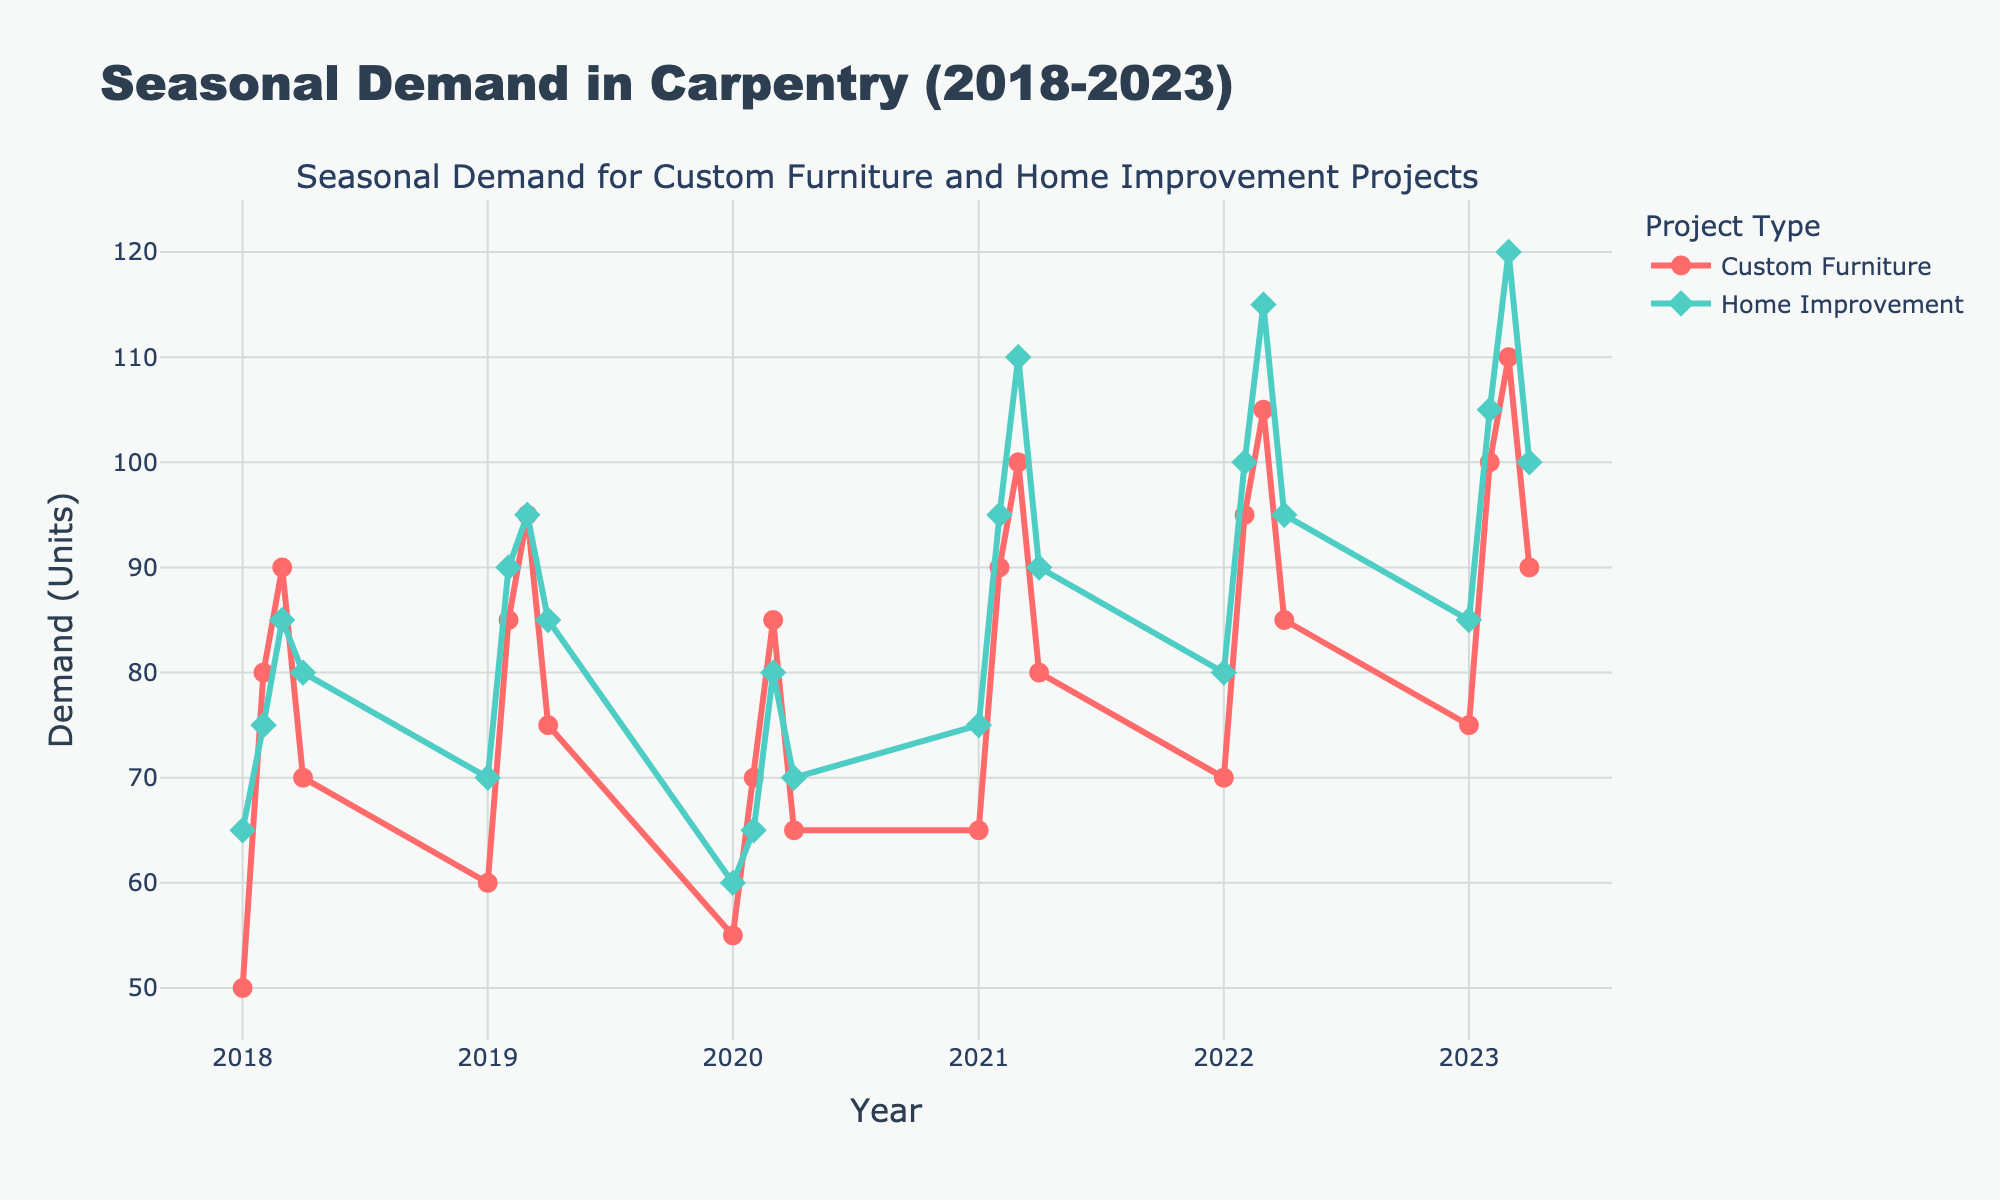What is the title of the plot? The title of the plot is located at the top center and summarizes the main content of the figure, which is the seasonal demand in carpentry from 2018 to 2023.
Answer: Seasonal Demand in Carpentry (2018-2023) How many data points are there for Custom Furniture Demand? By counting the markers or data points along the Custom Furniture Demand line in the plot, you can see there are 24 data points.
Answer: 24 What is the highest demand for Home Improvement Projects and when did it occur? The highest demand is marked by the peak point on the Home Improvement Projects line. This occurs at 120 units in Q3 of 2023.
Answer: 120 units, Q3 2023 In which quarter of which year did Custom Furniture Demand reach its lowest point? The lowest point on the Custom Furniture Demand line corresponds to the minimum value, which is 50 units in Q1 of 2018.
Answer: Q1 2018 What is the difference in demand between Custom Furniture and Home Improvement Projects in Q2 of 2022? Look at the values for both demands in Q2 of 2022 and subtract them. Custom Furniture Demand is 95 units and Home Improvement Projects Demand is 100 units. The difference is 100 - 95 = 5 units.
Answer: 5 units Which year saw the highest average quarterly demand for Custom Furniture? Calculate the average for each year by summing the quarterly values within the year and then dividing by 4. The year with the highest average is 2023: (75+100+110+90)/4 = 93.75 units.
Answer: 2023 How did the Home Improvement Projects Demand trend change from Q1 2020 to Q1 2021? Compare the demand values over the quarters in 2020 and 2021. From Q1 2020 to Q1 2021, the demand increased from 60 units to 75 units, indicating a rising trend.
Answer: Rising Did Custom Furniture Demand or Home Improvement Projects Demand have more growth from Q3 2018 to Q3 2019? Calculate the growth for each category from Q3 2018 to Q3 2019. For Custom Furniture: 95 - 90 = 5 units growth. For Home Improvement: 95 - 85 = 10 units growth.
Answer: Home Improvement Projects What is the median demand for Custom Furniture in 2021? The quarterly demand values for Custom Furniture in 2021 are 65, 90, 100, and 80. Arranging these in ascending order: 65, 80, 90, 100. The median is the average of the two middle values: (80 + 90) / 2 = 85.
Answer: 85 units Does the demand for Custom Furniture or Home Improvement Projects show more seasonality? By observing the patterns, Custom Furniture Demand has more noticeable peaks and troughs within each year, indicating stronger seasonality effects compared to Home Improvement Projects.
Answer: Custom Furniture 